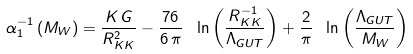Convert formula to latex. <formula><loc_0><loc_0><loc_500><loc_500>\alpha _ { 1 } ^ { - 1 } \left ( M _ { W } \right ) = \frac { K \, G } { R _ { K K } ^ { 2 } } - \frac { 7 6 } { 6 \, \pi } \ \ln \left ( \frac { R _ { K K } ^ { - 1 } } { \Lambda _ { G U T } } \right ) + \frac { 2 } { \pi } \ \ln \left ( \frac { \Lambda _ { G U T } } { M _ { W } } \right )</formula> 